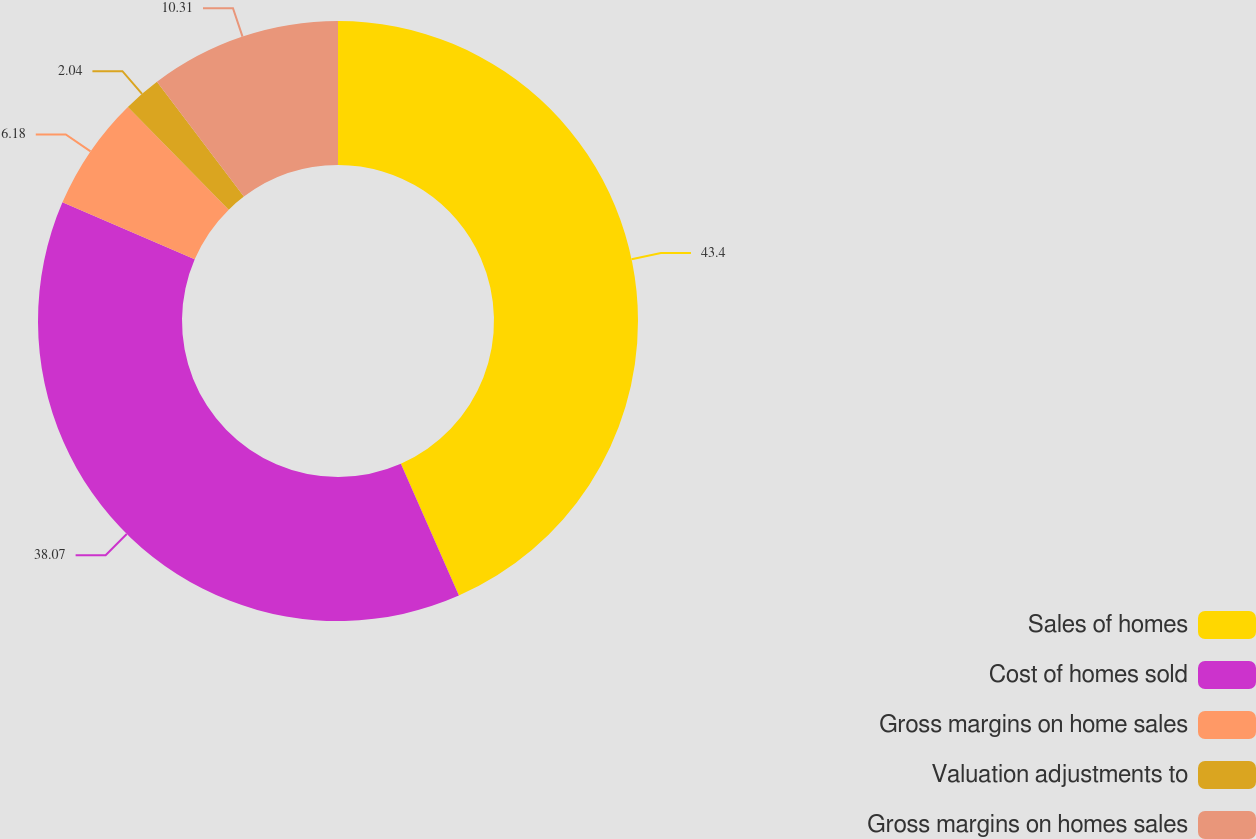Convert chart. <chart><loc_0><loc_0><loc_500><loc_500><pie_chart><fcel>Sales of homes<fcel>Cost of homes sold<fcel>Gross margins on home sales<fcel>Valuation adjustments to<fcel>Gross margins on homes sales<nl><fcel>43.4%<fcel>38.07%<fcel>6.18%<fcel>2.04%<fcel>10.31%<nl></chart> 